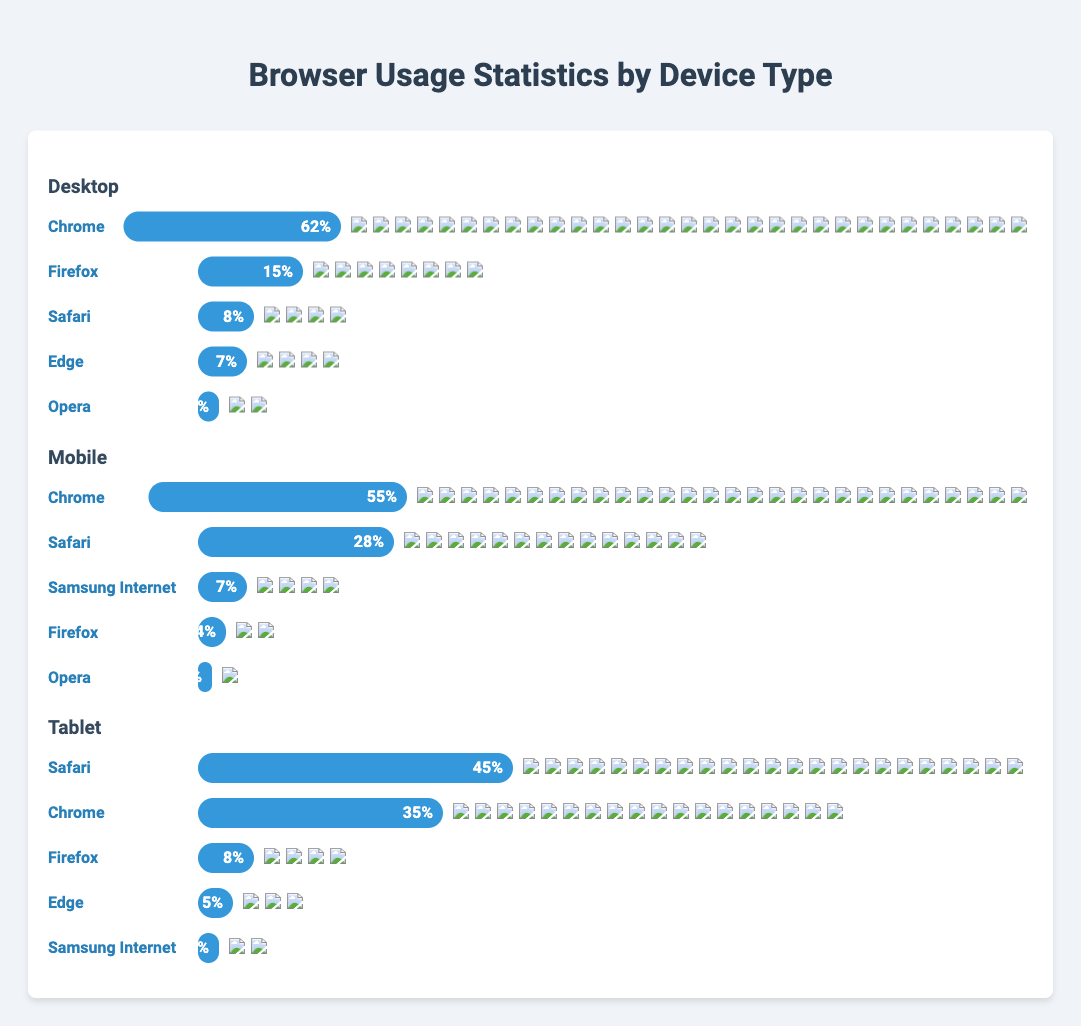What are the top three browsers used on Desktop devices? To identify the top three browsers used on Desktop devices, refer to the section labeled "Desktop" in the figure and look at the browsers listed. The usage percentages are Chrome (62%), Firefox (15%), and Safari (8%).
Answer: Chrome, Firefox, Safari Which device type has the highest usage of Chrome? Compare the usage of Chrome across all device types. On Desktop, Chrome is at 62%, on Mobile, it is 55%, and on Tablet, it is 35%. Since 62% is the highest percentage among these values, Desktop has the highest usage of Chrome.
Answer: Desktop How much more percentage does Safari have on Tablets compared to Mobile? Look at the Safari usage on both device types. Safari has a usage of 45% on Tablets and 28% on Mobile. Subtract Mobile's usage percentage from Tablet's usage percentage (45% - 28% = 17%).
Answer: 17% What's the total combined usage percentage of Firefox across all device types? Sum the usage percentages of Firefox for each device type. On Desktop, Firefox is at 15%, on Mobile, it is 4%, and on Tablet, it is 8%. Add these values together (15% + 4% + 8% = 27%).
Answer: 27% Is Opera more popular on Desktop or Mobile? Compare the usage percentage of Opera on Desktop and Mobile. On Desktop, Opera is at 3%, and on Mobile, it is 2%. Since 3% is greater than 2%, Opera is more popular on Desktop.
Answer: Desktop Which browser has the second-highest usage on Mobile devices? Refer to the Mobile section and look at the usage percentages. Chrome is the highest at 55%, and Safari follows at 28%, making Safari the second-highest.
Answer: Safari How does the usage of Firefox on Tablets compare to that on Desktops? Compare the Firefox usage percentages for Tablets and Desktops. Firefox usage is 8% on Tablets and 15% on Desktops. Since 15% is higher than 8%, Firefox is less used on Tablets than on Desktops.
Answer: Less on Tablets Which browser is the most used across all devices? Review the usage percentages of all browsers across all device types. Chrome appears with the highest percentages: 62% on Desktop, 55% on Mobile, and 35% on Tablet, making it the most used browser.
Answer: Chrome 